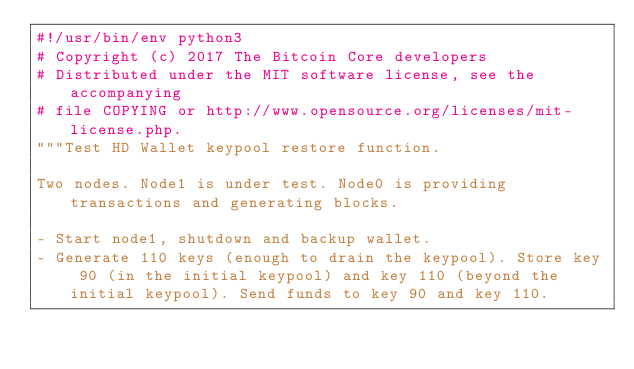<code> <loc_0><loc_0><loc_500><loc_500><_Python_>#!/usr/bin/env python3
# Copyright (c) 2017 The Bitcoin Core developers
# Distributed under the MIT software license, see the accompanying
# file COPYING or http://www.opensource.org/licenses/mit-license.php.
"""Test HD Wallet keypool restore function.

Two nodes. Node1 is under test. Node0 is providing transactions and generating blocks.

- Start node1, shutdown and backup wallet.
- Generate 110 keys (enough to drain the keypool). Store key 90 (in the initial keypool) and key 110 (beyond the initial keypool). Send funds to key 90 and key 110.</code> 